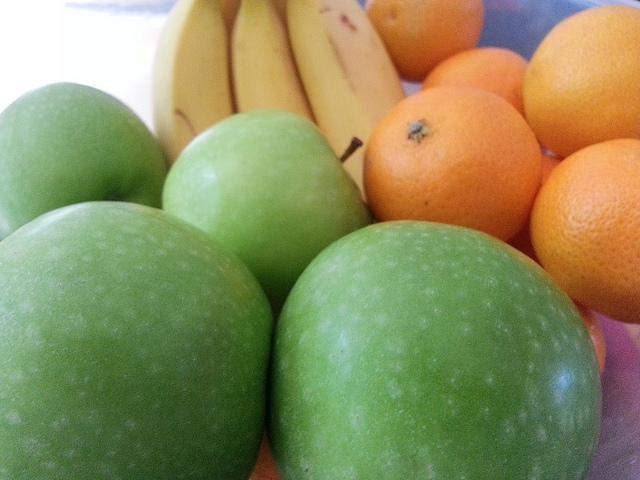What is the green item used in?

Choices:
A) cheeseburger
B) pea soup
C) apple pie
D) caesar salad apple pie 